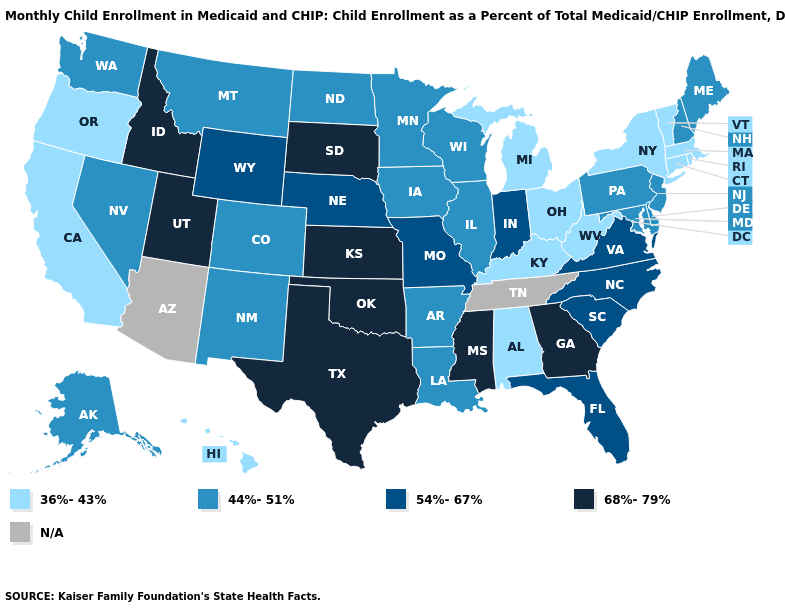Does New Mexico have the lowest value in the West?
Give a very brief answer. No. Which states hav the highest value in the Northeast?
Write a very short answer. Maine, New Hampshire, New Jersey, Pennsylvania. Does the map have missing data?
Write a very short answer. Yes. What is the value of Connecticut?
Short answer required. 36%-43%. How many symbols are there in the legend?
Concise answer only. 5. What is the lowest value in the Northeast?
Give a very brief answer. 36%-43%. Name the states that have a value in the range 68%-79%?
Concise answer only. Georgia, Idaho, Kansas, Mississippi, Oklahoma, South Dakota, Texas, Utah. What is the lowest value in the Northeast?
Quick response, please. 36%-43%. What is the highest value in the West ?
Give a very brief answer. 68%-79%. What is the value of New York?
Give a very brief answer. 36%-43%. What is the value of Wisconsin?
Write a very short answer. 44%-51%. Among the states that border Oklahoma , does Missouri have the highest value?
Concise answer only. No. Among the states that border Iowa , does South Dakota have the highest value?
Concise answer only. Yes. Does Michigan have the highest value in the MidWest?
Keep it brief. No. 